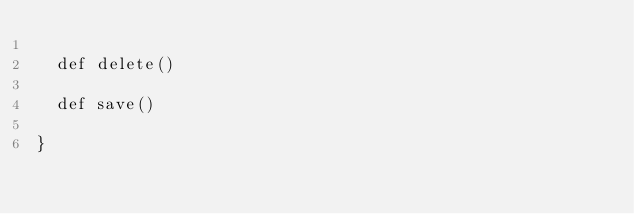<code> <loc_0><loc_0><loc_500><loc_500><_Scala_>  
  def delete()
  
  def save()

}</code> 